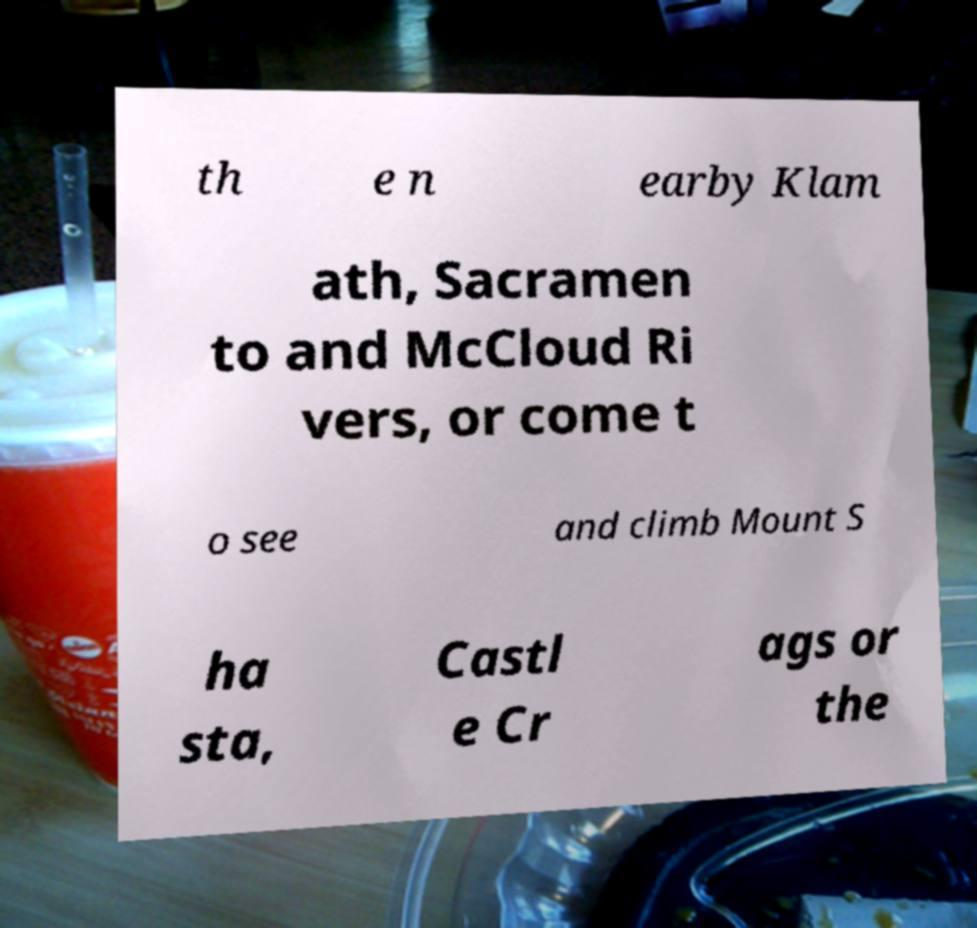What messages or text are displayed in this image? I need them in a readable, typed format. th e n earby Klam ath, Sacramen to and McCloud Ri vers, or come t o see and climb Mount S ha sta, Castl e Cr ags or the 